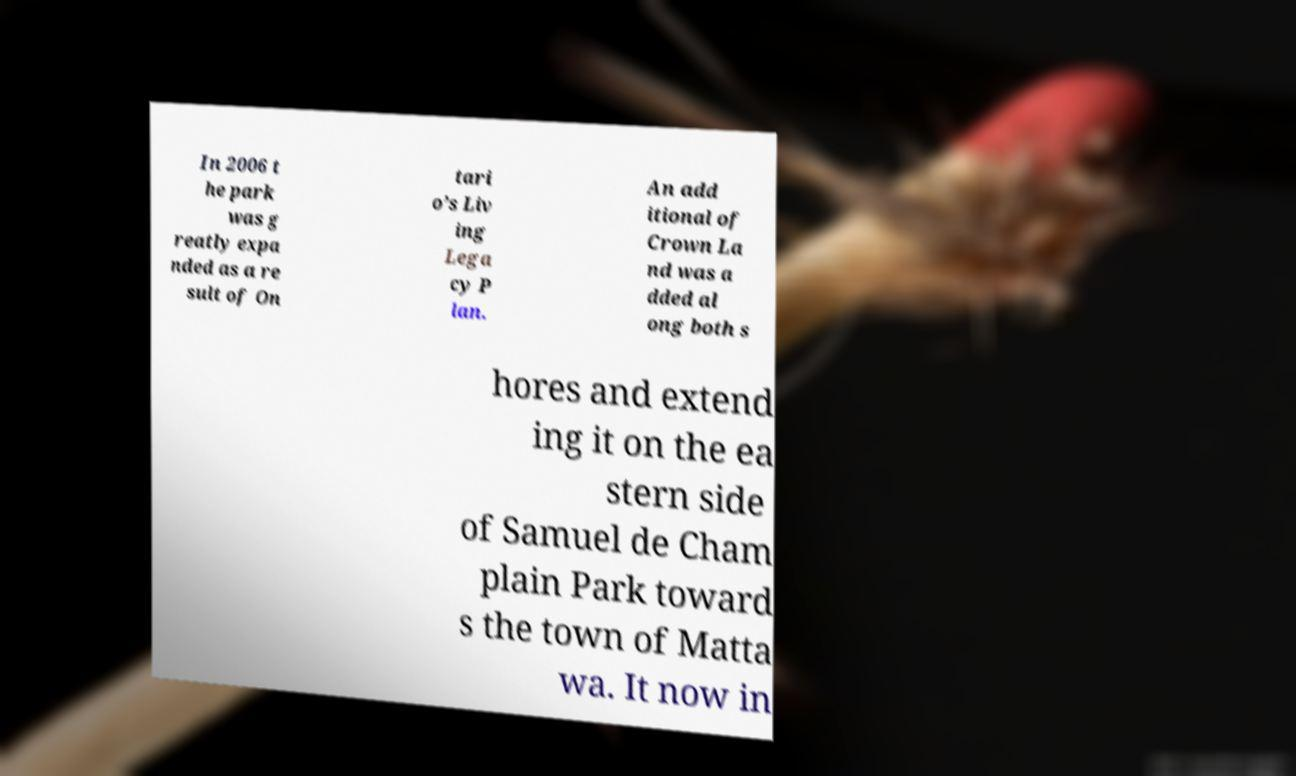Can you read and provide the text displayed in the image?This photo seems to have some interesting text. Can you extract and type it out for me? In 2006 t he park was g reatly expa nded as a re sult of On tari o’s Liv ing Lega cy P lan. An add itional of Crown La nd was a dded al ong both s hores and extend ing it on the ea stern side of Samuel de Cham plain Park toward s the town of Matta wa. It now in 